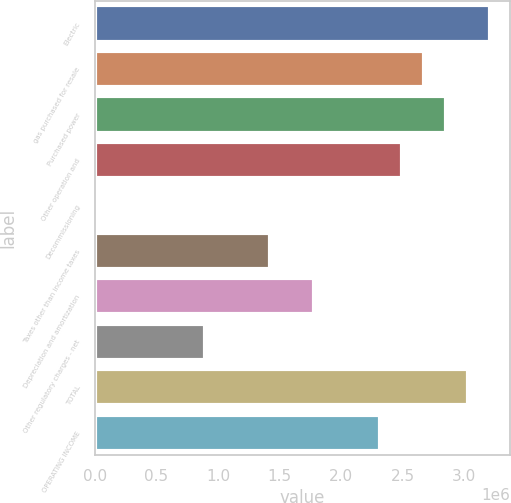Convert chart. <chart><loc_0><loc_0><loc_500><loc_500><bar_chart><fcel>Electric<fcel>gas purchased for resale<fcel>Purchased power<fcel>Other operation and<fcel>Decommissioning<fcel>Taxes other than income taxes<fcel>Depreciation and amortization<fcel>Other regulatory charges - net<fcel>TOTAL<fcel>OPERATING INCOME<nl><fcel>3.20912e+06<fcel>2.6743e+06<fcel>2.85257e+06<fcel>2.49602e+06<fcel>173<fcel>1.42637e+06<fcel>1.78292e+06<fcel>891548<fcel>3.03085e+06<fcel>2.31775e+06<nl></chart> 